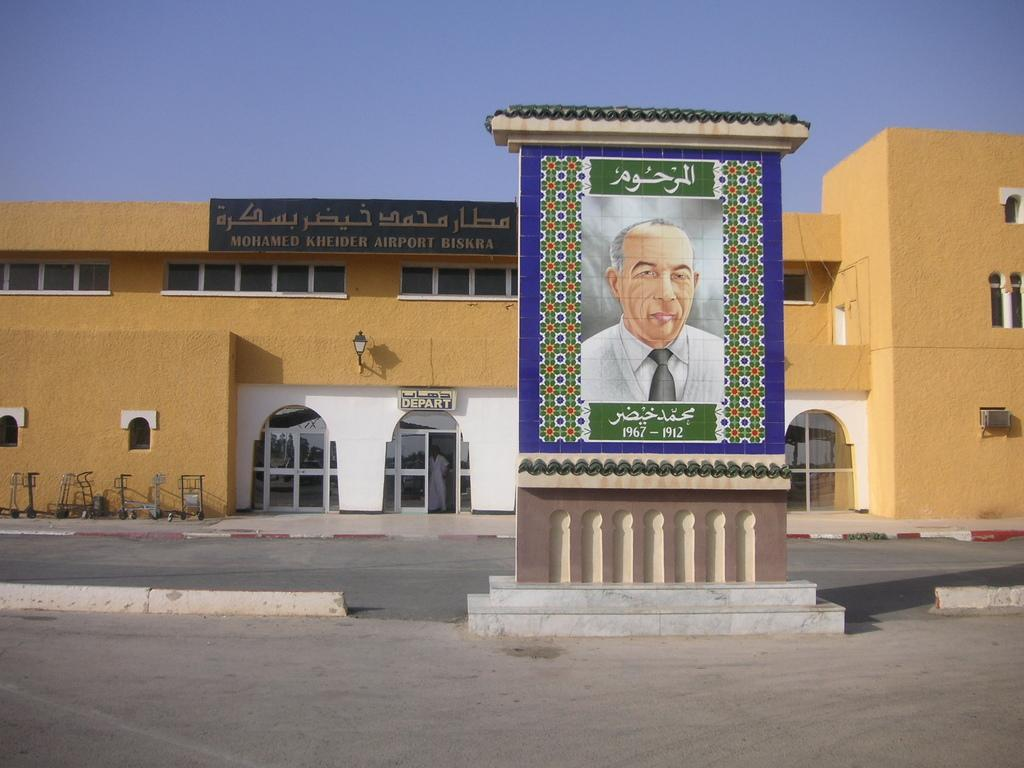What type of building is shown in the image? The image shows the front view of an airport building. Can you describe any specific features of the building? The provided facts do not mention any specific features of the building. What might be located inside the airport building? The image only shows the exterior of the building, so it is not possible to determine what is located inside. What type of celery can be seen growing on the roof of the airport building in the image? There is no celery visible on the roof of the airport building in the image. 